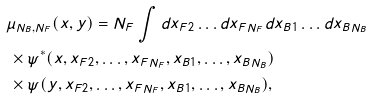Convert formula to latex. <formula><loc_0><loc_0><loc_500><loc_500>& \mu _ { N _ { B } , N _ { F } } ( x , y ) = N _ { F } \int d x _ { F 2 } \dots d x _ { F N _ { F } } d x _ { B 1 } \dots d x _ { B N _ { B } } \\ & \, \times \psi ^ { * } ( x , x _ { F 2 } , \dots , x _ { F N _ { F } } , x _ { B 1 } , \dots , x _ { B N _ { B } } ) \\ & \, \times \psi ( y , x _ { F 2 } , \dots , x _ { F N _ { F } } , x _ { B 1 } , \dots , x _ { B N _ { B } } ) ,</formula> 